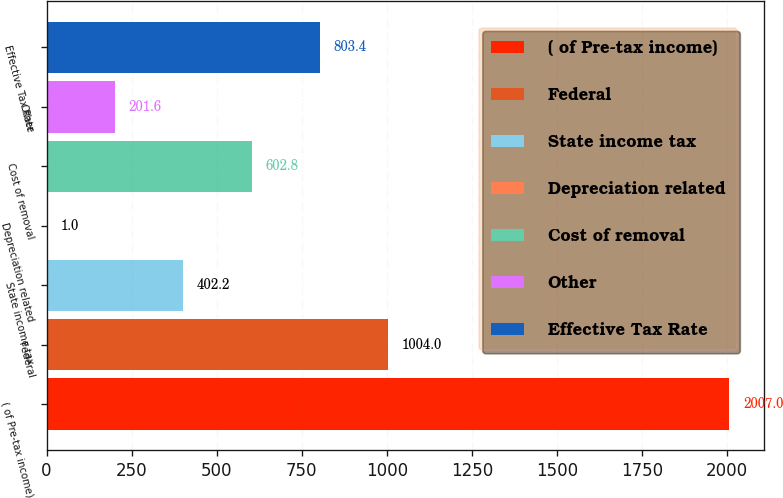<chart> <loc_0><loc_0><loc_500><loc_500><bar_chart><fcel>( of Pre-tax income)<fcel>Federal<fcel>State income tax<fcel>Depreciation related<fcel>Cost of removal<fcel>Other<fcel>Effective Tax Rate<nl><fcel>2007<fcel>1004<fcel>402.2<fcel>1<fcel>602.8<fcel>201.6<fcel>803.4<nl></chart> 